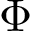Convert formula to latex. <formula><loc_0><loc_0><loc_500><loc_500>\Phi</formula> 